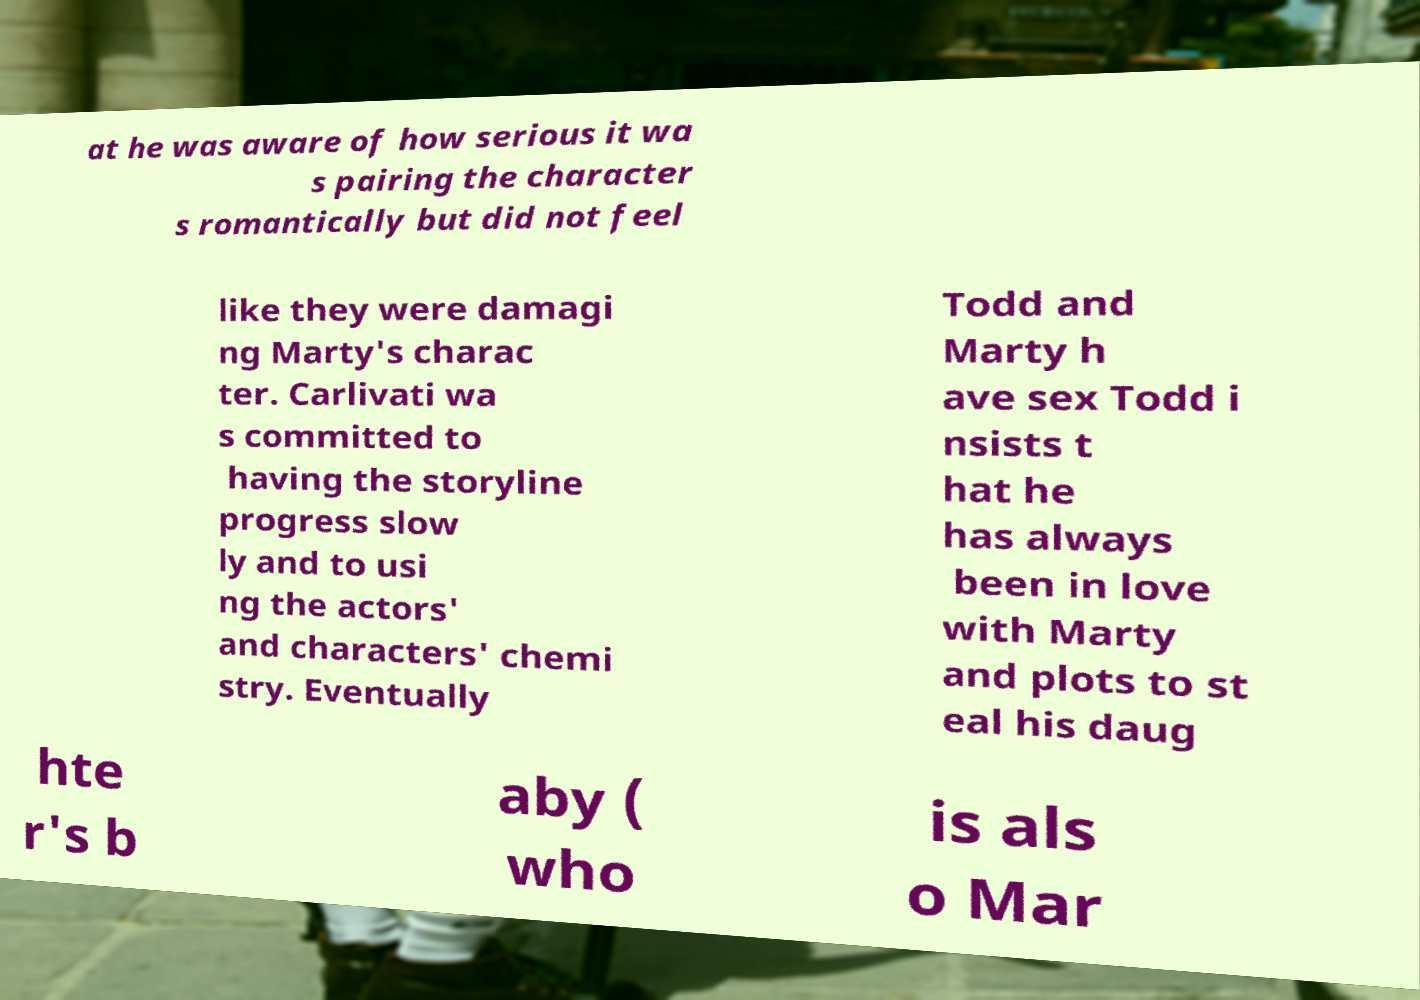Can you read and provide the text displayed in the image?This photo seems to have some interesting text. Can you extract and type it out for me? at he was aware of how serious it wa s pairing the character s romantically but did not feel like they were damagi ng Marty's charac ter. Carlivati wa s committed to having the storyline progress slow ly and to usi ng the actors' and characters' chemi stry. Eventually Todd and Marty h ave sex Todd i nsists t hat he has always been in love with Marty and plots to st eal his daug hte r's b aby ( who is als o Mar 